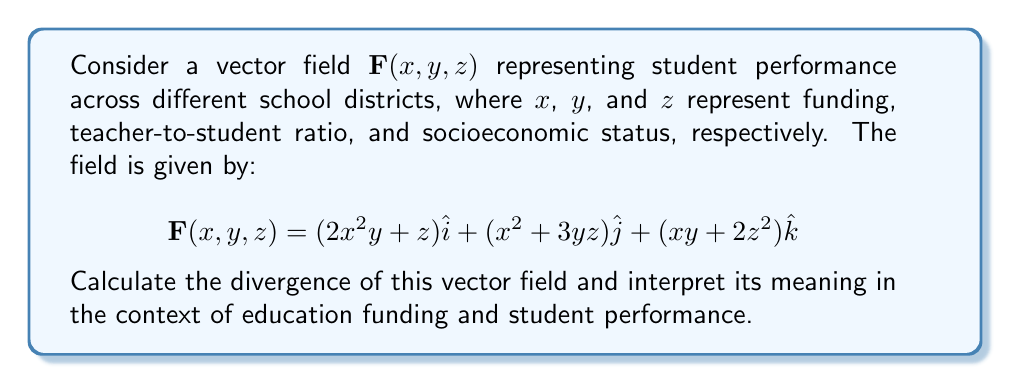Give your solution to this math problem. To calculate the divergence of the vector field, we need to find the sum of the partial derivatives of each component with respect to its corresponding variable:

$$\text{div}\mathbf{F} = \nabla \cdot \mathbf{F} = \frac{\partial F_x}{\partial x} + \frac{\partial F_y}{\partial y} + \frac{\partial F_z}{\partial z}$$

Let's calculate each partial derivative:

1. $\frac{\partial F_x}{\partial x} = \frac{\partial}{\partial x}(2x^2y + z) = 4xy$

2. $\frac{\partial F_y}{\partial y} = \frac{\partial}{\partial y}(x^2 + 3yz) = 3z$

3. $\frac{\partial F_z}{\partial z} = \frac{\partial}{\partial z}(xy + 2z^2) = 4z$

Now, we sum these partial derivatives:

$$\text{div}\mathbf{F} = 4xy + 3z + 4z = 4xy + 7z$$

Interpretation:
The divergence represents the rate at which student performance is changing with respect to the three factors (funding, teacher-to-student ratio, and socioeconomic status) at any given point. A positive divergence indicates that student performance is improving as these factors increase.

In this case, the divergence $4xy + 7z$ suggests that:
1. Increasing funding $(x)$ and improving teacher-to-student ratio $(y)$ together have a positive impact on student performance, as shown by the term $4xy$.
2. Improving socioeconomic status $(z)$ also has a positive impact on student performance, as indicated by the term $7z$.
3. The impact of socioeconomic status is independent of the other factors, while funding and teacher-to-student ratio have a combined effect.

This result supports the persona's belief that increased education funding is necessary for providing quality education, as it shows a positive relationship between funding and student performance when combined with improved teacher-to-student ratios.
Answer: $\text{div}\mathbf{F} = 4xy + 7z$ 